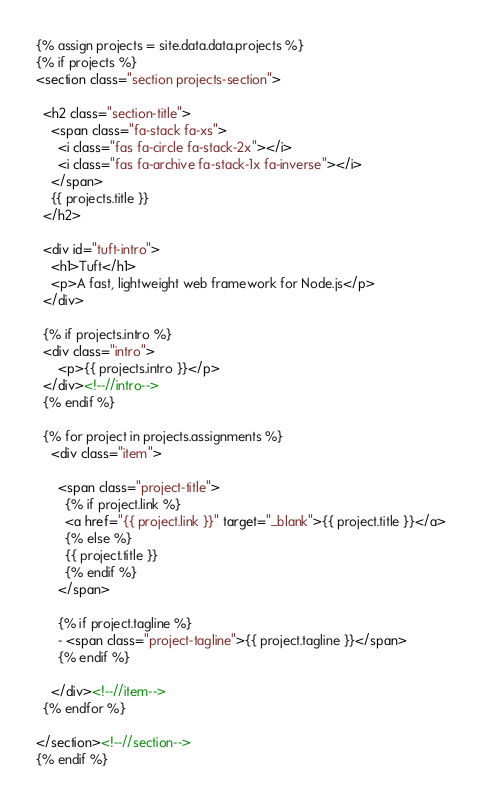<code> <loc_0><loc_0><loc_500><loc_500><_HTML_>{% assign projects = site.data.data.projects %}
{% if projects %}
<section class="section projects-section">

  <h2 class="section-title">
    <span class="fa-stack fa-xs">
      <i class="fas fa-circle fa-stack-2x"></i>
      <i class="fas fa-archive fa-stack-1x fa-inverse"></i>
    </span>
    {{ projects.title }}
  </h2>

  <div id="tuft-intro">
    <h1>Tuft</h1>
    <p>A fast, lightweight web framework for Node.js</p>
  </div>

  {% if projects.intro %}
  <div class="intro">
      <p>{{ projects.intro }}</p>
  </div><!--//intro-->
  {% endif %}

  {% for project in projects.assignments %}
    <div class="item">

      <span class="project-title">
        {% if project.link %}
        <a href="{{ project.link }}" target="_blank">{{ project.title }}</a>
        {% else %}
        {{ project.title }}
        {% endif %}
      </span>

      {% if project.tagline %}
      - <span class="project-tagline">{{ project.tagline }}</span>
      {% endif %}

    </div><!--//item-->
  {% endfor %}

</section><!--//section-->
{% endif %}
</code> 